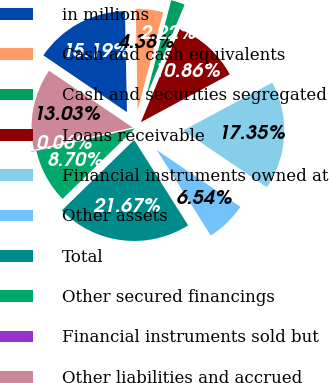<chart> <loc_0><loc_0><loc_500><loc_500><pie_chart><fcel>in millions<fcel>Cash and cash equivalents<fcel>Cash and securities segregated<fcel>Loans receivable<fcel>Financial instruments owned at<fcel>Other assets<fcel>Total<fcel>Other secured financings<fcel>Financial instruments sold but<fcel>Other liabilities and accrued<nl><fcel>15.19%<fcel>4.38%<fcel>2.22%<fcel>10.86%<fcel>17.35%<fcel>6.54%<fcel>21.67%<fcel>8.7%<fcel>0.06%<fcel>13.03%<nl></chart> 